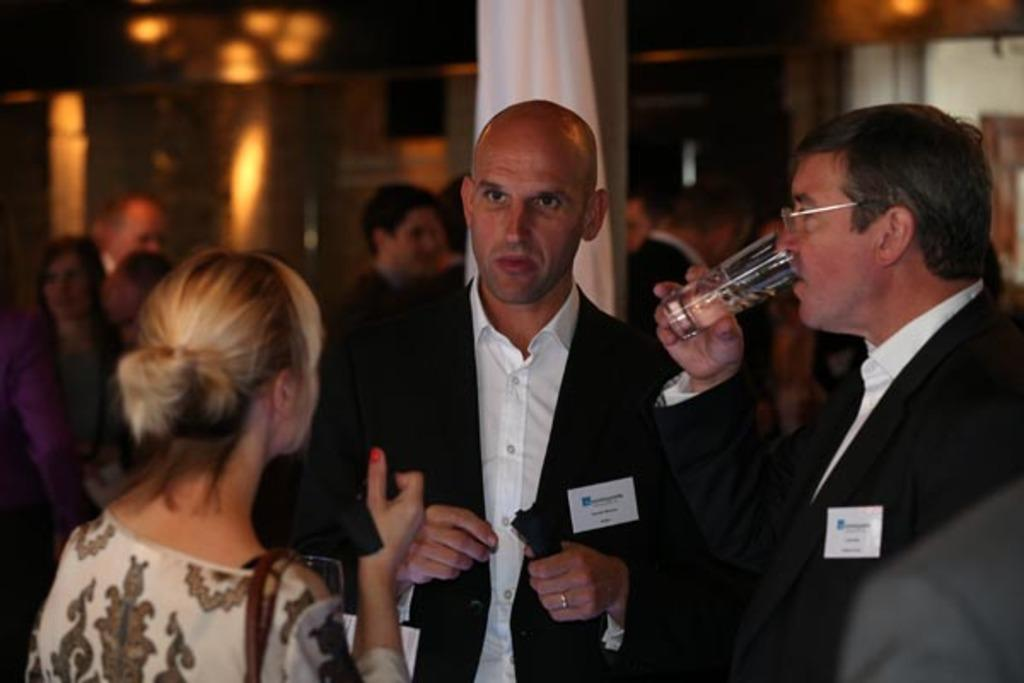What is the main subject in the middle of the image? There is a man standing in the middle of the image. What is the man in the middle wearing? The man in the middle is wearing a coat. What is the man on the right side of the image doing? The man on the right side is drinking liquid from a glass. What is the woman on the left side of the image wearing? The woman on the left side is wearing a dress. What is the robin thinking about in the image? There is no robin present in the image, so it is not possible to determine what the robin might be thinking about. 